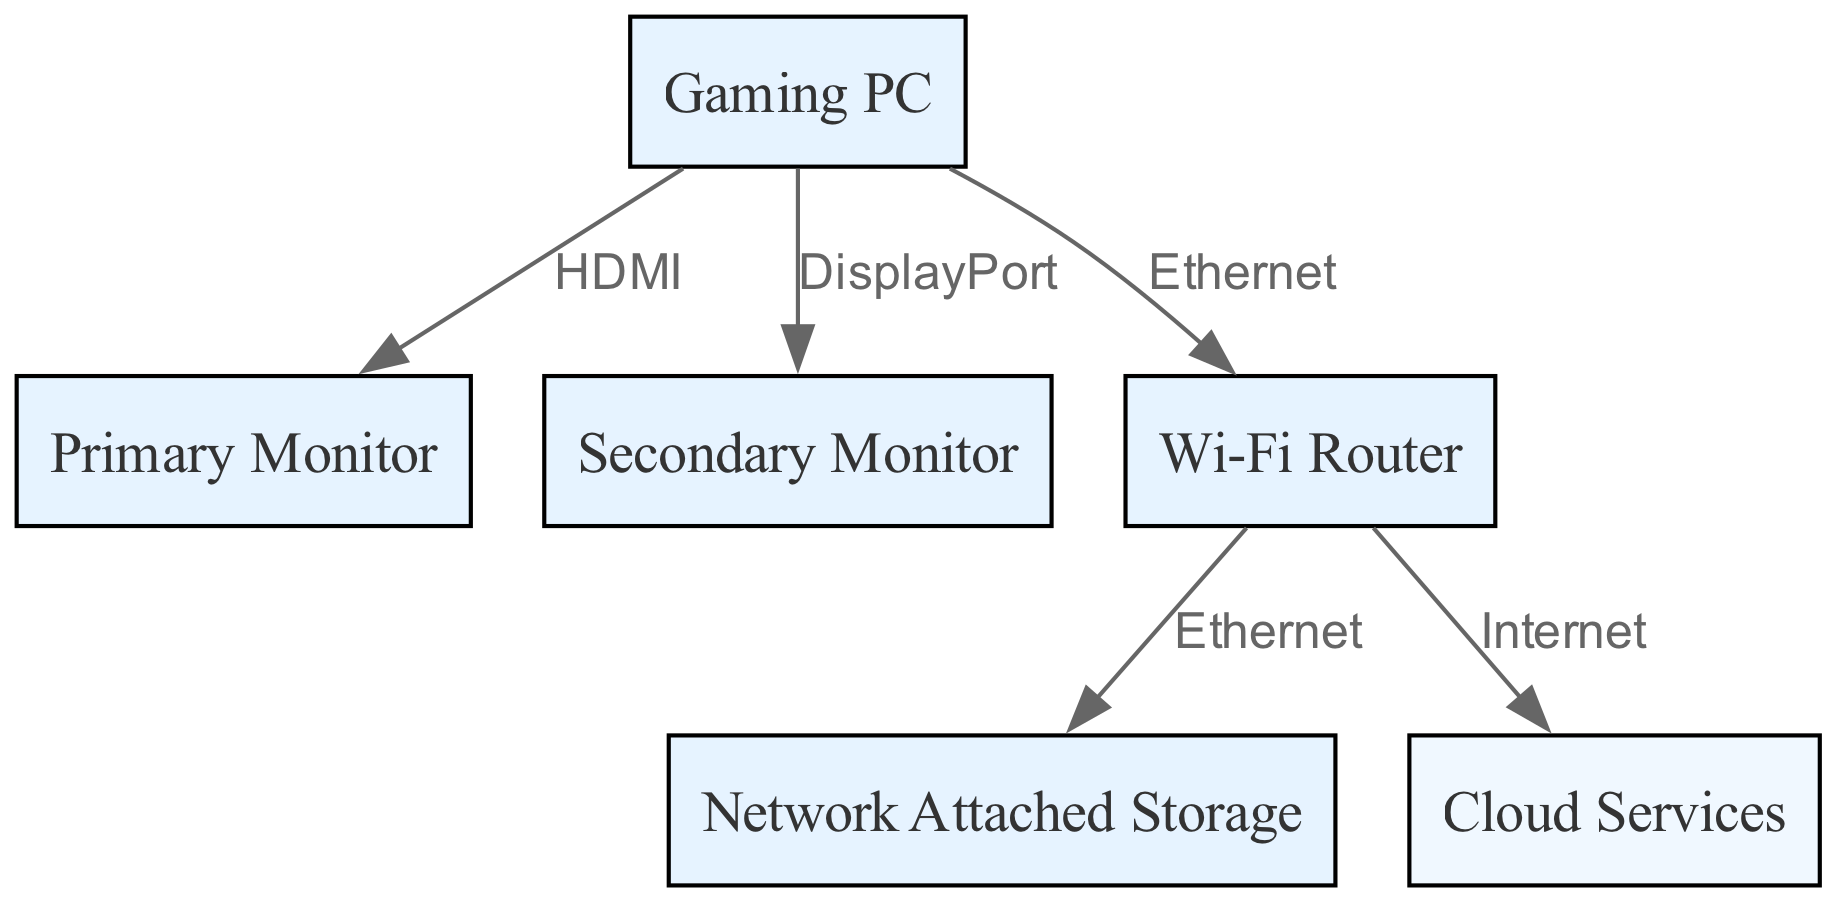What are the two types of monitors in this setup? Looking at the nodes in the diagram, the labels for the monitors are "Primary Monitor" and "Secondary Monitor".
Answer: Primary Monitor, Secondary Monitor How many nodes are present in the diagram? By counting the different components listed in the nodes section—Gaming PC, Primary Monitor, Secondary Monitor, Wi-Fi Router, Network Attached Storage, and Cloud Services—there are a total of six nodes.
Answer: 6 What connection does the Gaming PC use to connect to the Primary Monitor? In the edges section, it states that the relationship between the Gaming PC and the Primary Monitor is via an "HDMI" connection.
Answer: HDMI Which device connects to the Network Attached Storage? The diagram indicates that the Wi-Fi Router is connected directly to the Network Attached Storage using an Ethernet cable, as shown in the edges section.
Answer: Wi-Fi Router What type of storage is represented in this diagram? The node labeled "Network Attached Storage" indicates that this is a kind of storage specifically meant for network access, thus representing storage that is accessible over a network.
Answer: Network Attached Storage What type of connection does the router use to access the cloud services? The diagram shows that the router connects to cloud services via the "Internet" connection, which is classified as an external connection reflected in the edges.
Answer: Internet Which device is the central point of this network? The Gaming PC can be considered the central point of this network as it connects to both monitors and has a direct connection to the router, which is the hub for other connections.
Answer: Gaming PC How many edges are in this diagram? The edges section includes five connections: Gaming PC to Primary Monitor, Gaming PC to Secondary Monitor, Gaming PC to Router, Router to NAS, and Router to Cloud, totaling five edges overall.
Answer: 5 What type of connections exists between the router and NAS? The diagram specifies that the connection from the router to the NAS is an "Ethernet" connection, indicating a wired connection type for transferring data between these devices.
Answer: Ethernet 